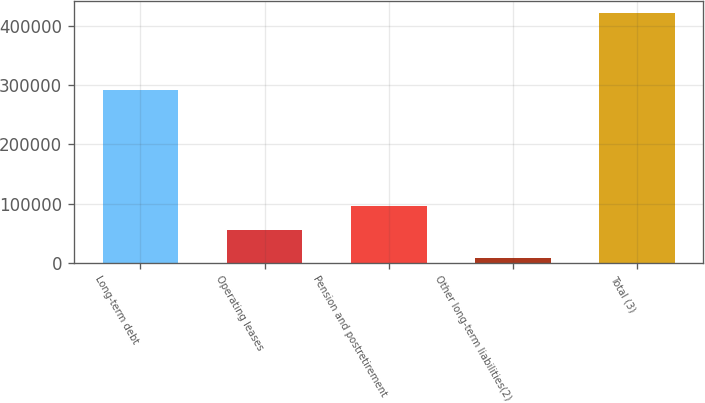Convert chart to OTSL. <chart><loc_0><loc_0><loc_500><loc_500><bar_chart><fcel>Long-term debt<fcel>Operating leases<fcel>Pension and postretirement<fcel>Other long-term liabilities(2)<fcel>Total (3)<nl><fcel>291095<fcel>54628<fcel>95958.6<fcel>8322<fcel>421628<nl></chart> 